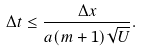Convert formula to latex. <formula><loc_0><loc_0><loc_500><loc_500>\Delta t \leq \frac { \Delta x } { a ( m + 1 ) \sqrt { U } } .</formula> 